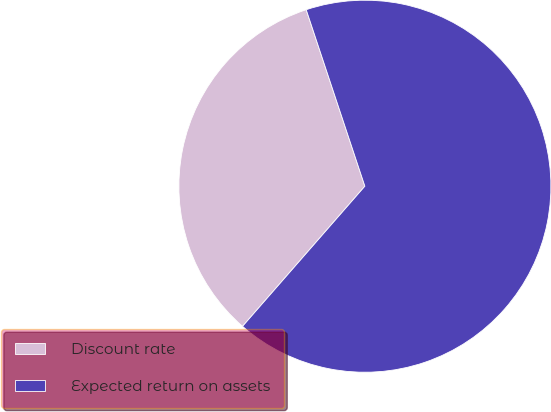<chart> <loc_0><loc_0><loc_500><loc_500><pie_chart><fcel>Discount rate<fcel>Expected return on assets<nl><fcel>33.47%<fcel>66.53%<nl></chart> 